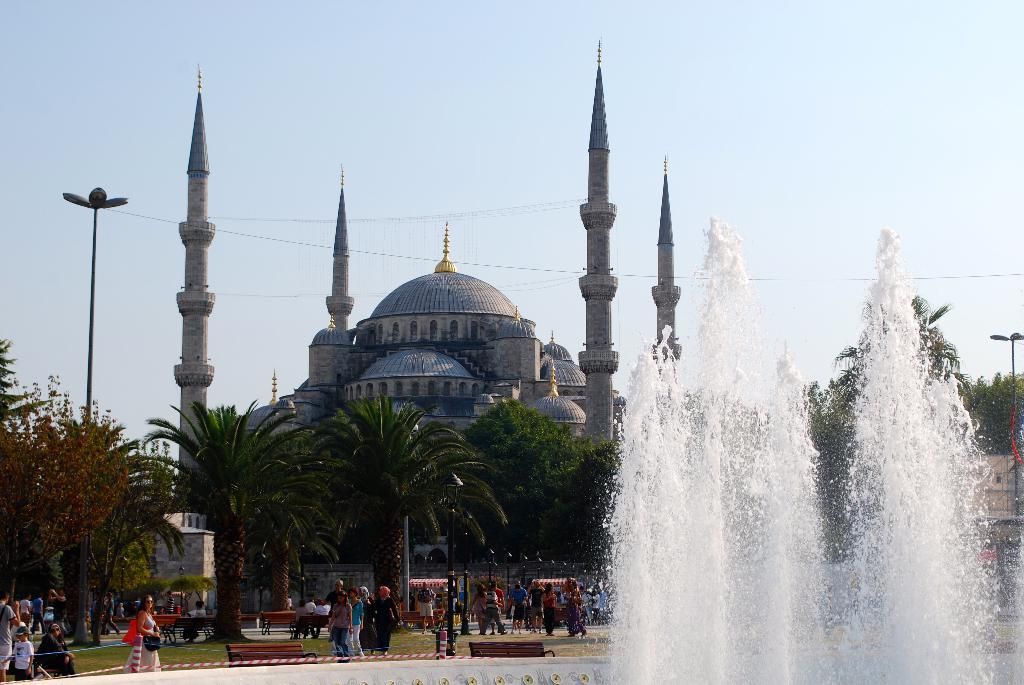What type of natural environment is depicted in the image? There are trees in a park in the image. What are the people in the image doing? There are people walking in the image. Where are the benches located in the image? The benches are near a fountain in the image. What can be seen in the background of the image? There is a monument and the sky visible in the background of the image. How many beans are scattered on the ground near the monument in the image? There are no beans present in the image; it features a park with trees, people walking, benches near a fountain, a monument, and the sky visible in the background. What type of badge is being worn by the people walking in the image? There is no mention of any badges being worn by the people walking in the image. 